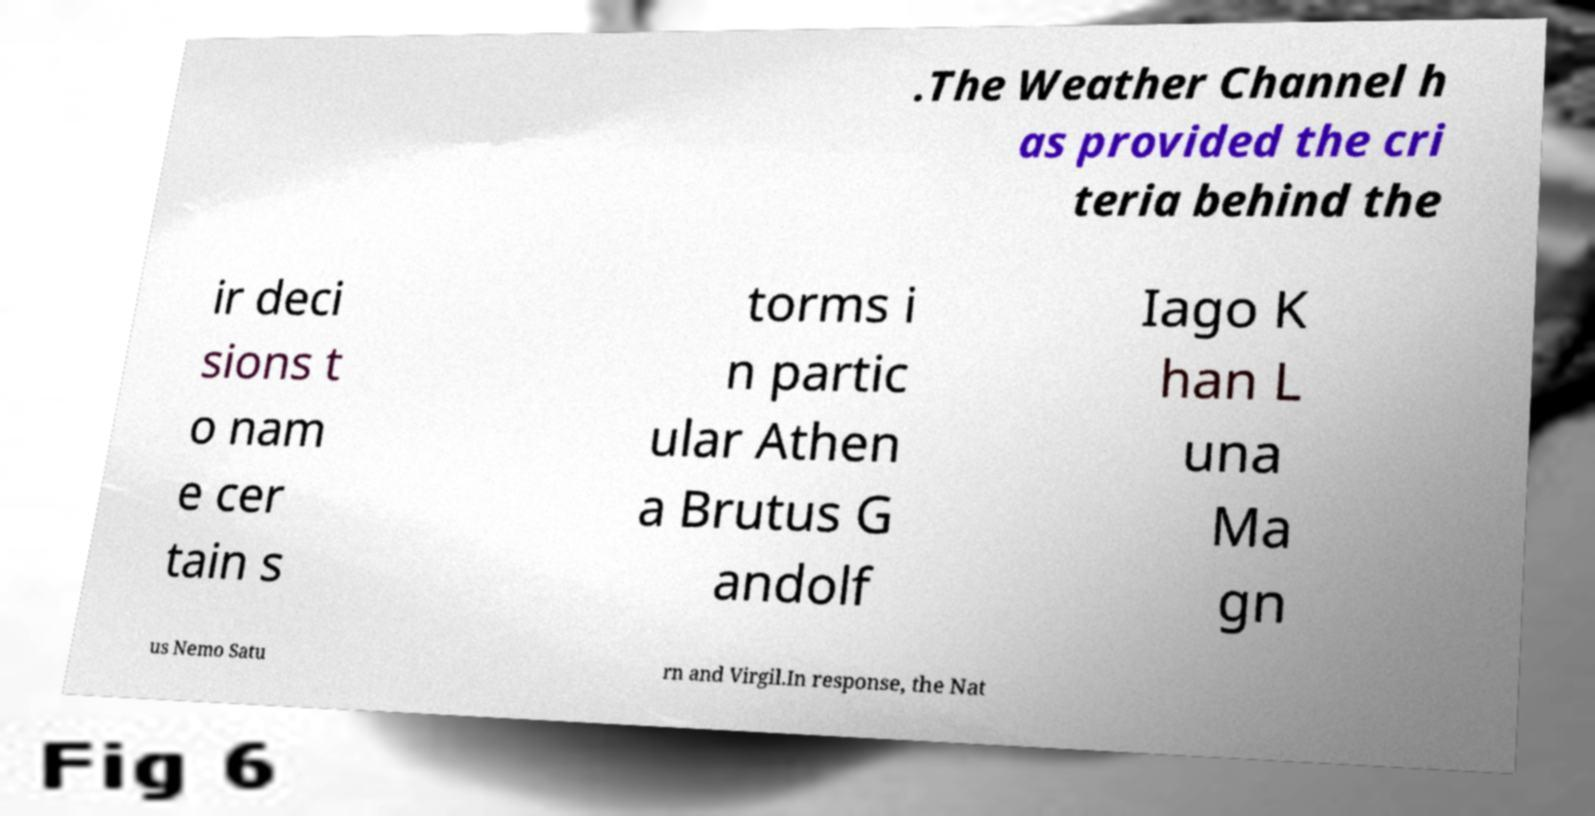Please identify and transcribe the text found in this image. .The Weather Channel h as provided the cri teria behind the ir deci sions t o nam e cer tain s torms i n partic ular Athen a Brutus G andolf Iago K han L una Ma gn us Nemo Satu rn and Virgil.In response, the Nat 